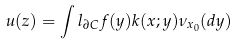<formula> <loc_0><loc_0><loc_500><loc_500>u ( z ) = \int l _ { \partial C } f ( y ) k ( x ; y ) \nu _ { x _ { 0 } } ( d y )</formula> 